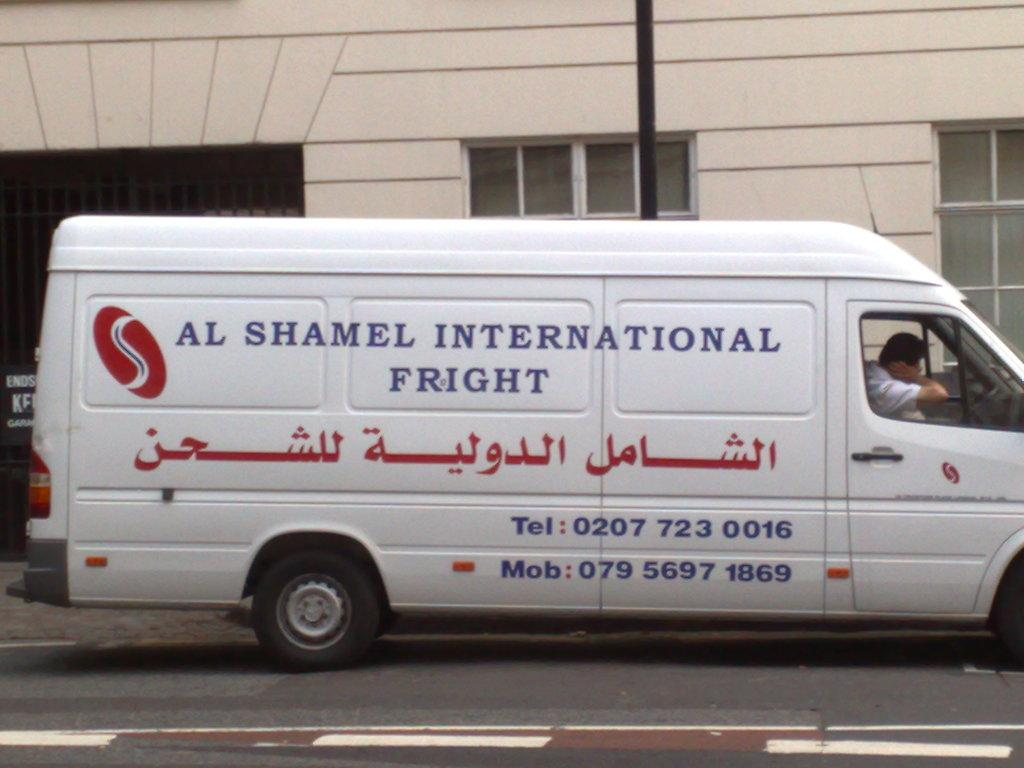<image>
Share a concise interpretation of the image provided. A man drives a white van depicting the company name Al Shamel International Fright. 